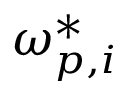<formula> <loc_0><loc_0><loc_500><loc_500>\omega _ { p , i } ^ { * }</formula> 